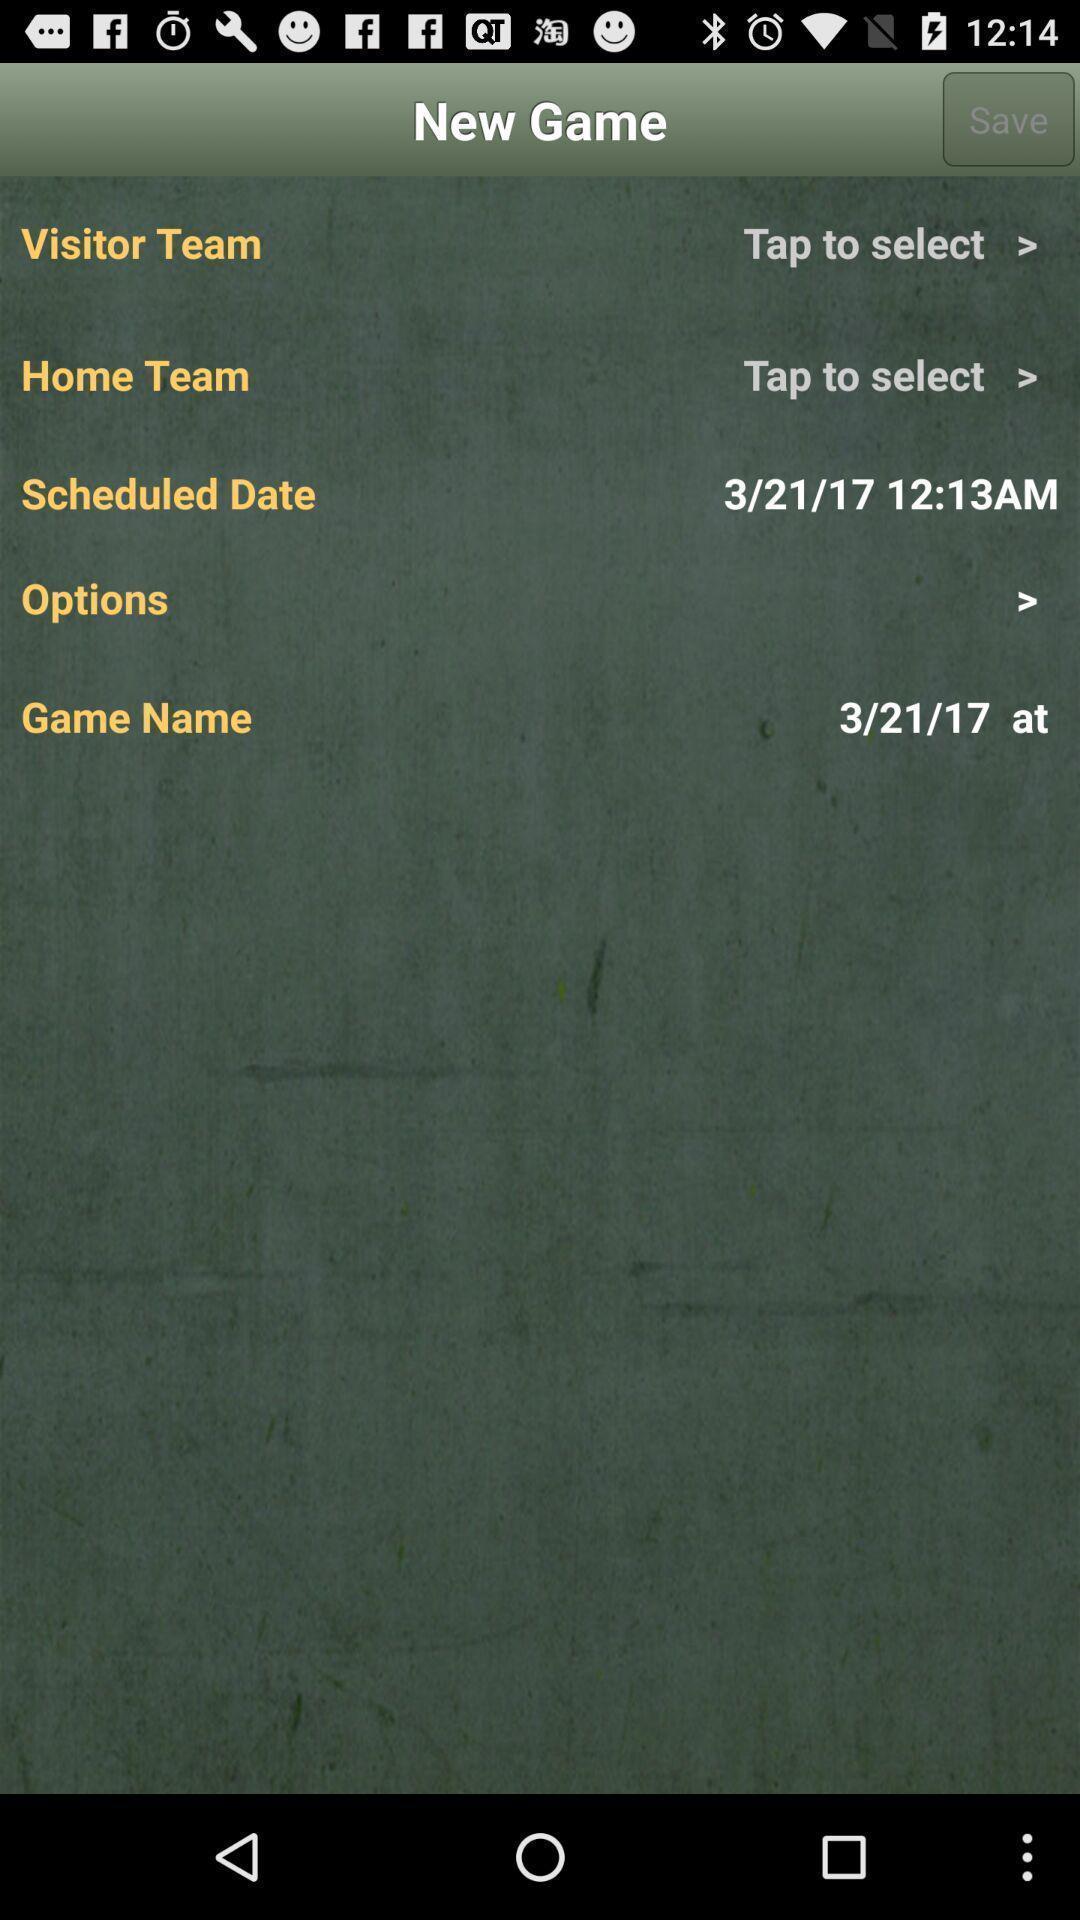Summarize the main components in this picture. Scheduled date displaying in application. 